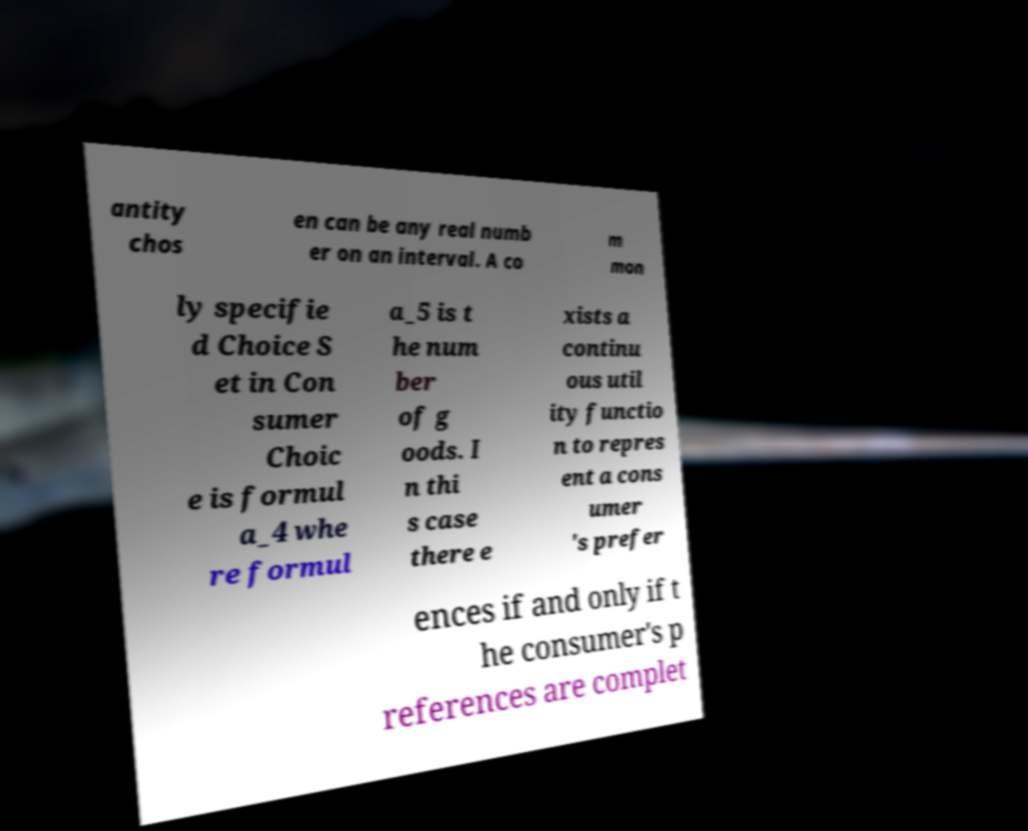Could you extract and type out the text from this image? antity chos en can be any real numb er on an interval. A co m mon ly specifie d Choice S et in Con sumer Choic e is formul a_4 whe re formul a_5 is t he num ber of g oods. I n thi s case there e xists a continu ous util ity functio n to repres ent a cons umer 's prefer ences if and only if t he consumer's p references are complet 